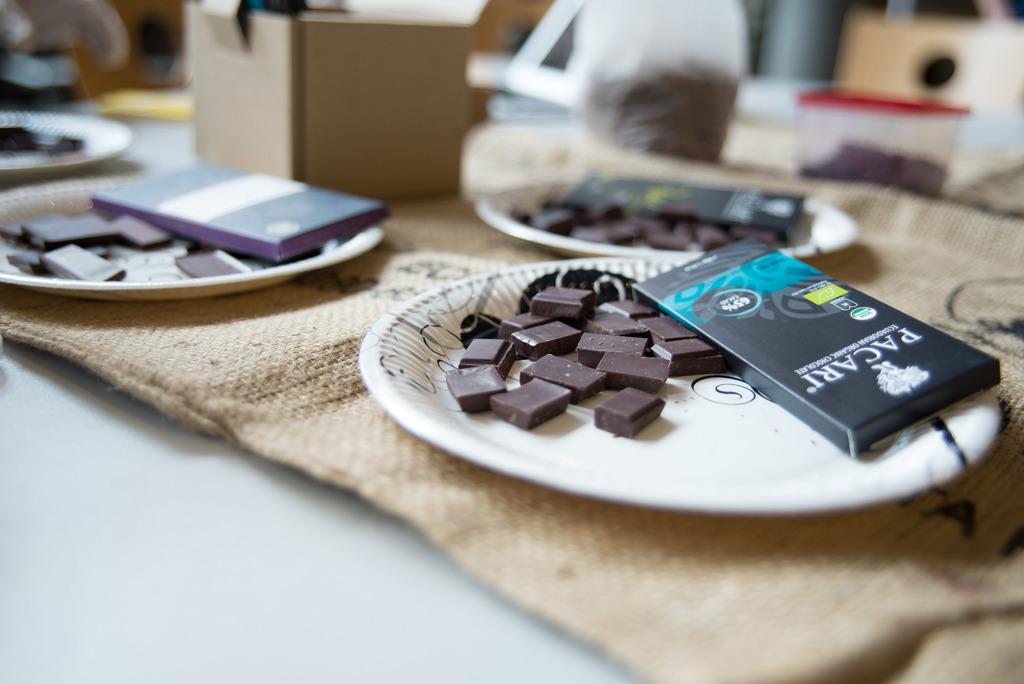What brand is the candy closest to the right corner?
Provide a succinct answer. Pacari. What percentage of chocolate is this candy?
Offer a very short reply. Unanswerable. 